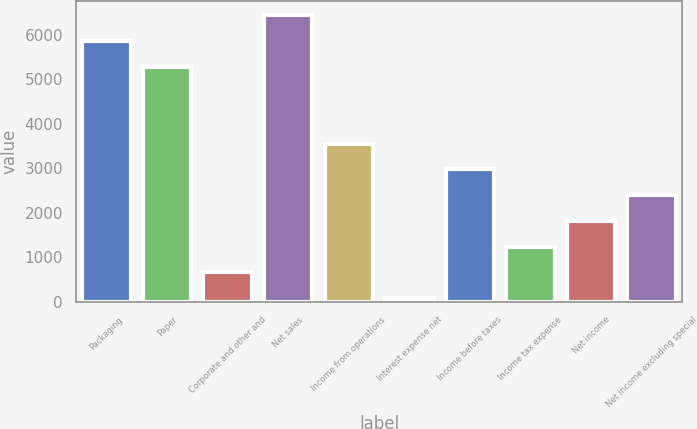<chart> <loc_0><loc_0><loc_500><loc_500><bar_chart><fcel>Packaging<fcel>Paper<fcel>Corporate and other and<fcel>Net sales<fcel>Income from operations<fcel>Interest expense net<fcel>Income before taxes<fcel>Income tax expense<fcel>Net income<fcel>Net income excluding special<nl><fcel>5852.6<fcel>5276.18<fcel>664.82<fcel>6429.02<fcel>3546.92<fcel>88.4<fcel>2970.5<fcel>1241.24<fcel>1817.66<fcel>2394.08<nl></chart> 